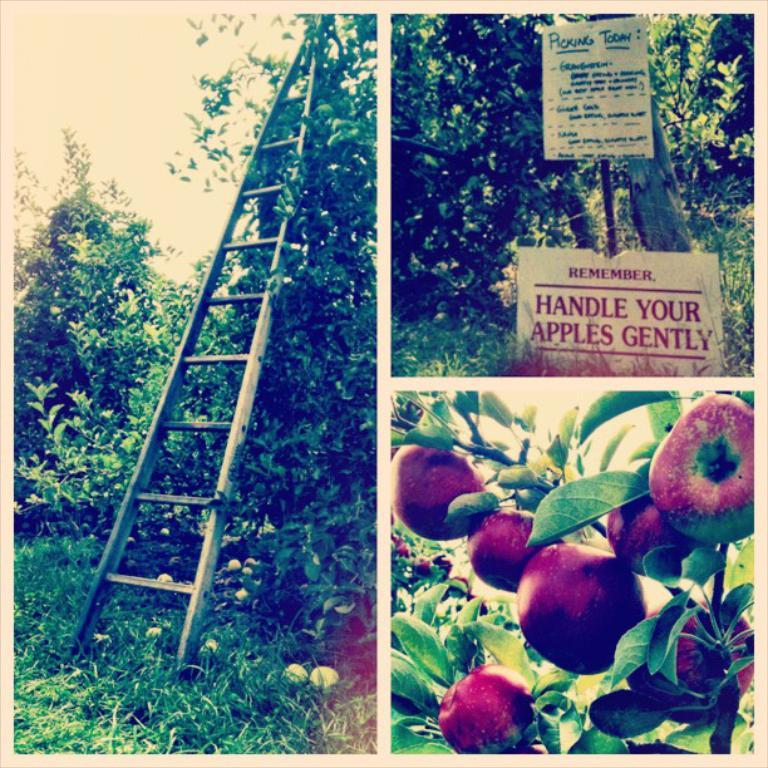What type of vegetation can be seen in the image? The image contains trees and grass. Are there any informational resources in the image? Yes, there are informational boards in the image. What object is used for climbing in the image? A ladder is present in the image. What type of food can be seen in the image? Fruits are visible in the image. What color is the shirt worn by the animal in the image? There is no animal or shirt present in the image. 